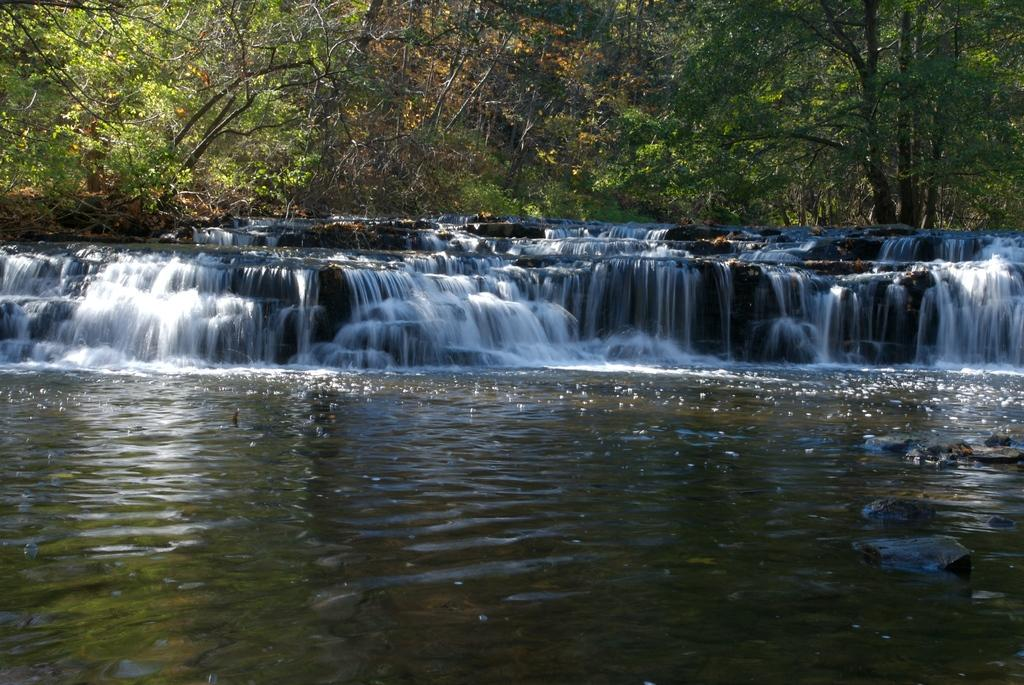What is the main feature in the foreground of the image? There is a waterfall in the foreground of the image. What else can be seen in the foreground of the image? There is a water body in the foreground of the image. What type of vegetation is visible in the background of the image? There are trees in the background of the image. How much payment is required to enter the waterfall in the image? There is no indication of any payment or entrance fee in the image; it simply shows a waterfall and a water body. What type of camera was used to capture the image? The type of camera used to capture the image is not mentioned in the image or the provided facts. 